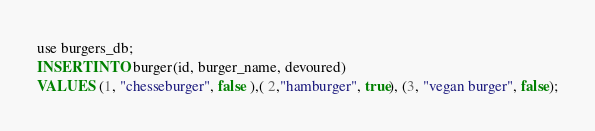<code> <loc_0><loc_0><loc_500><loc_500><_SQL_>use burgers_db;
INSERT INTO burger(id, burger_name, devoured)
VALUES (1, "chesseburger", false ),( 2,"hamburger", true), (3, "vegan burger", false);</code> 